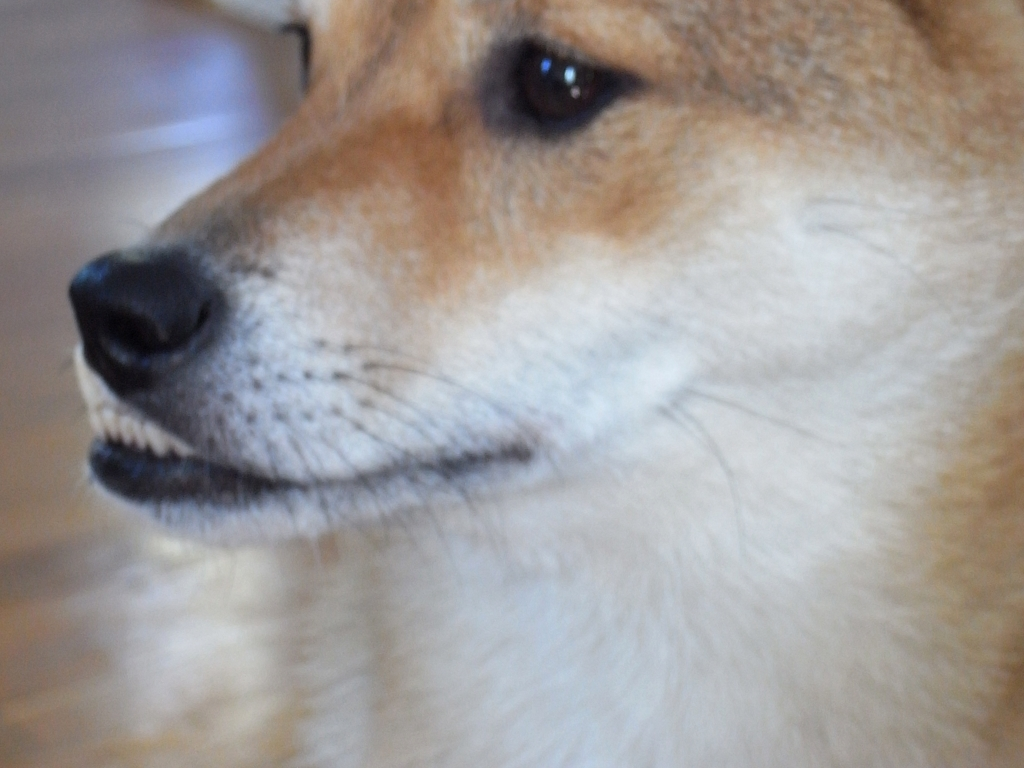What emotion might the dog be expressing? While interpreting an animal's emotion based on a single image can be speculative, the dog's relaxed facial expression, soft gaze, and slightly open mouth could imply a state of calmness or mild curiosity. It does not show signs of stress, such as narrowed eyes or pulled-back ears, which can often be observed in canines. The overall impression is that the dog is in a comfortable and familiar environment. 